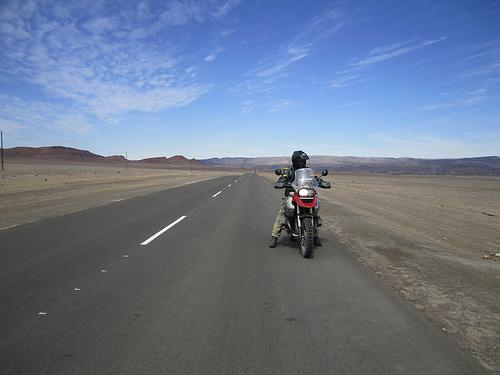Question: where was the photo taken?
Choices:
A. On the road.
B. At the dance.
C. Riverbank.
D. Camping.
Answer with the letter. Answer: A Question: what is blue?
Choices:
A. Sky.
B. The flower.
C. The car.
D. The water.
Answer with the letter. Answer: A Question: what is dark gray?
Choices:
A. The shirt.
B. The building.
C. Street.
D. The elephant.
Answer with the letter. Answer: C Question: what is in the distance?
Choices:
A. The city.
B. The ocean.
C. A field.
D. Mountains.
Answer with the letter. Answer: D Question: where are clouds?
Choices:
A. In space.
B. In the sky.
C. On the ground.
D. In the ocean.
Answer with the letter. Answer: B Question: where are white lines?
Choices:
A. On a shirt.
B. On the sign.
C. On the street.
D. On the car.
Answer with the letter. Answer: C 